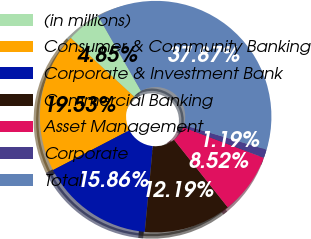Convert chart. <chart><loc_0><loc_0><loc_500><loc_500><pie_chart><fcel>(in millions)<fcel>Consumer & Community Banking<fcel>Corporate & Investment Bank<fcel>Commercial Banking<fcel>Asset Management<fcel>Corporate<fcel>Total<nl><fcel>4.85%<fcel>19.53%<fcel>15.86%<fcel>12.19%<fcel>8.52%<fcel>1.19%<fcel>37.87%<nl></chart> 